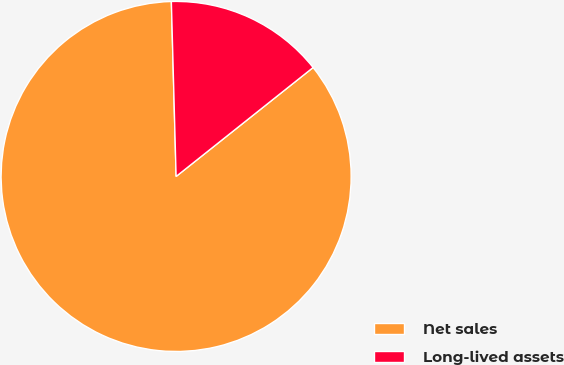Convert chart. <chart><loc_0><loc_0><loc_500><loc_500><pie_chart><fcel>Net sales<fcel>Long-lived assets<nl><fcel>85.26%<fcel>14.74%<nl></chart> 